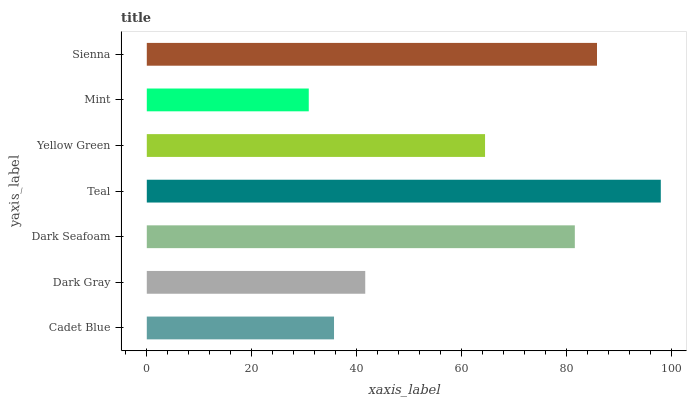Is Mint the minimum?
Answer yes or no. Yes. Is Teal the maximum?
Answer yes or no. Yes. Is Dark Gray the minimum?
Answer yes or no. No. Is Dark Gray the maximum?
Answer yes or no. No. Is Dark Gray greater than Cadet Blue?
Answer yes or no. Yes. Is Cadet Blue less than Dark Gray?
Answer yes or no. Yes. Is Cadet Blue greater than Dark Gray?
Answer yes or no. No. Is Dark Gray less than Cadet Blue?
Answer yes or no. No. Is Yellow Green the high median?
Answer yes or no. Yes. Is Yellow Green the low median?
Answer yes or no. Yes. Is Dark Seafoam the high median?
Answer yes or no. No. Is Teal the low median?
Answer yes or no. No. 